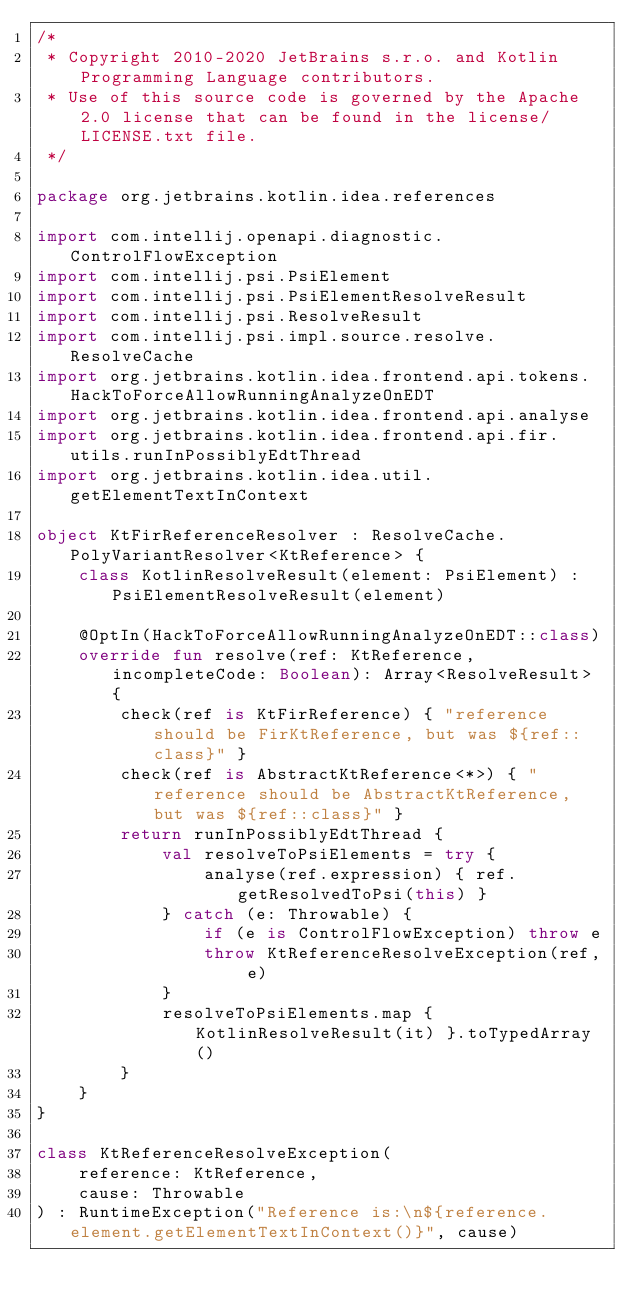<code> <loc_0><loc_0><loc_500><loc_500><_Kotlin_>/*
 * Copyright 2010-2020 JetBrains s.r.o. and Kotlin Programming Language contributors.
 * Use of this source code is governed by the Apache 2.0 license that can be found in the license/LICENSE.txt file.
 */

package org.jetbrains.kotlin.idea.references

import com.intellij.openapi.diagnostic.ControlFlowException
import com.intellij.psi.PsiElement
import com.intellij.psi.PsiElementResolveResult
import com.intellij.psi.ResolveResult
import com.intellij.psi.impl.source.resolve.ResolveCache
import org.jetbrains.kotlin.idea.frontend.api.tokens.HackToForceAllowRunningAnalyzeOnEDT
import org.jetbrains.kotlin.idea.frontend.api.analyse
import org.jetbrains.kotlin.idea.frontend.api.fir.utils.runInPossiblyEdtThread
import org.jetbrains.kotlin.idea.util.getElementTextInContext

object KtFirReferenceResolver : ResolveCache.PolyVariantResolver<KtReference> {
    class KotlinResolveResult(element: PsiElement) : PsiElementResolveResult(element)

    @OptIn(HackToForceAllowRunningAnalyzeOnEDT::class)
    override fun resolve(ref: KtReference, incompleteCode: Boolean): Array<ResolveResult> {
        check(ref is KtFirReference) { "reference should be FirKtReference, but was ${ref::class}" }
        check(ref is AbstractKtReference<*>) { "reference should be AbstractKtReference, but was ${ref::class}" }
        return runInPossiblyEdtThread {
            val resolveToPsiElements = try {
                analyse(ref.expression) { ref.getResolvedToPsi(this) }
            } catch (e: Throwable) {
                if (e is ControlFlowException) throw e
                throw KtReferenceResolveException(ref, e)
            }
            resolveToPsiElements.map { KotlinResolveResult(it) }.toTypedArray()
        }
    }
}

class KtReferenceResolveException(
    reference: KtReference,
    cause: Throwable
) : RuntimeException("Reference is:\n${reference.element.getElementTextInContext()}", cause)</code> 